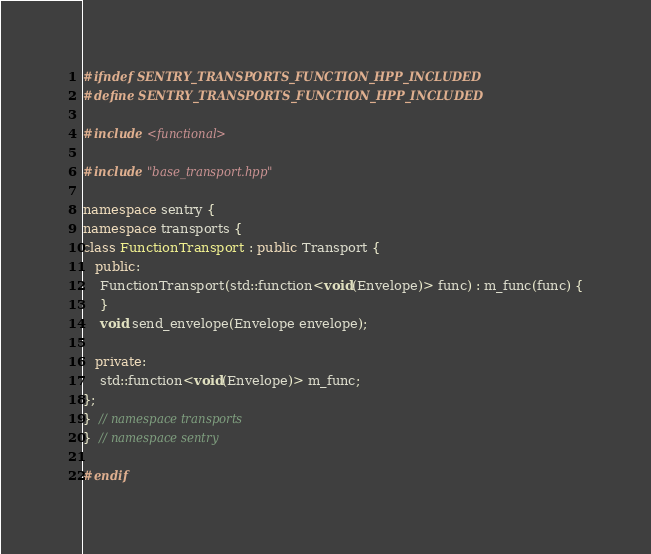<code> <loc_0><loc_0><loc_500><loc_500><_C++_>#ifndef SENTRY_TRANSPORTS_FUNCTION_HPP_INCLUDED
#define SENTRY_TRANSPORTS_FUNCTION_HPP_INCLUDED

#include <functional>

#include "base_transport.hpp"

namespace sentry {
namespace transports {
class FunctionTransport : public Transport {
   public:
    FunctionTransport(std::function<void(Envelope)> func) : m_func(func) {
    }
    void send_envelope(Envelope envelope);

   private:
    std::function<void(Envelope)> m_func;
};
}  // namespace transports
}  // namespace sentry

#endif
</code> 